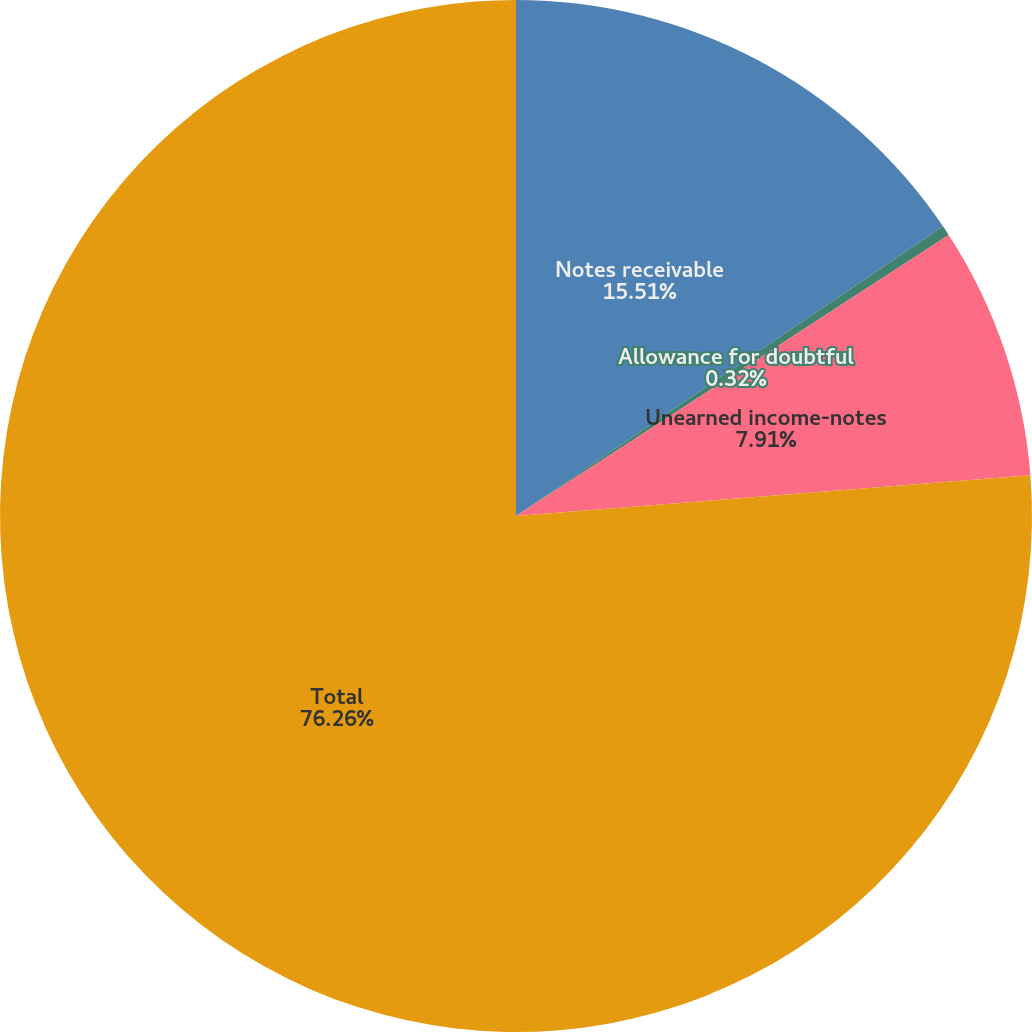<chart> <loc_0><loc_0><loc_500><loc_500><pie_chart><fcel>Notes receivable<fcel>Allowance for doubtful<fcel>Unearned income-notes<fcel>Total<nl><fcel>15.51%<fcel>0.32%<fcel>7.91%<fcel>76.26%<nl></chart> 